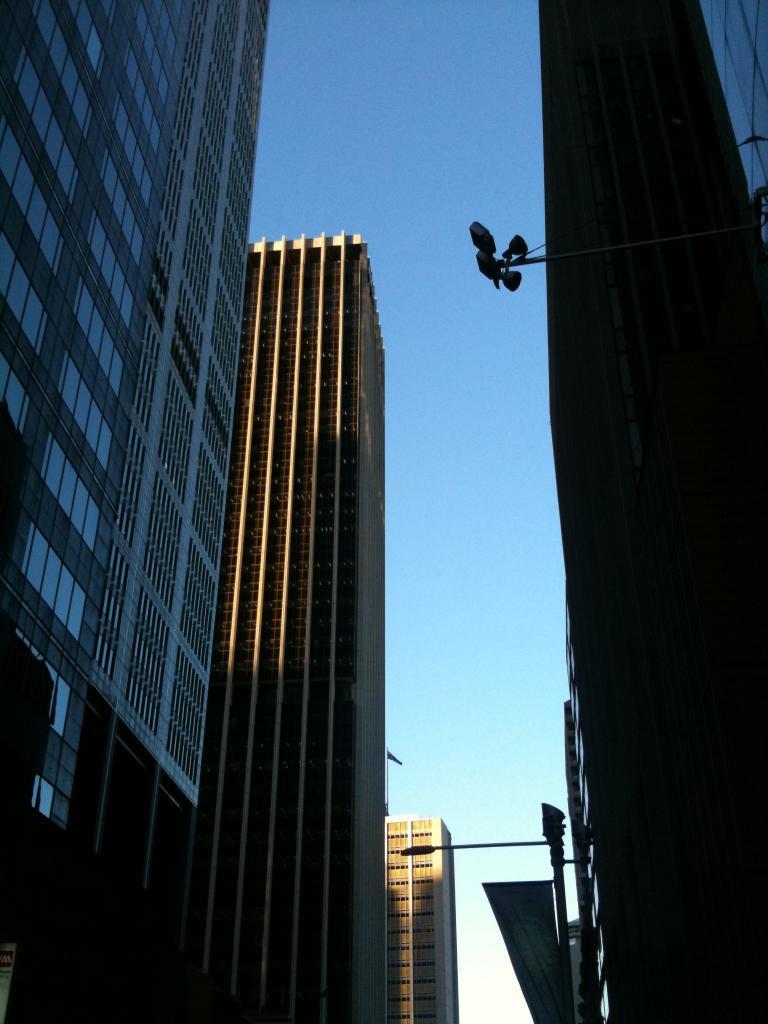Please provide a concise description of this image. In this image, we can see buildings, lights and there is a pole. At the top, there is sky. 